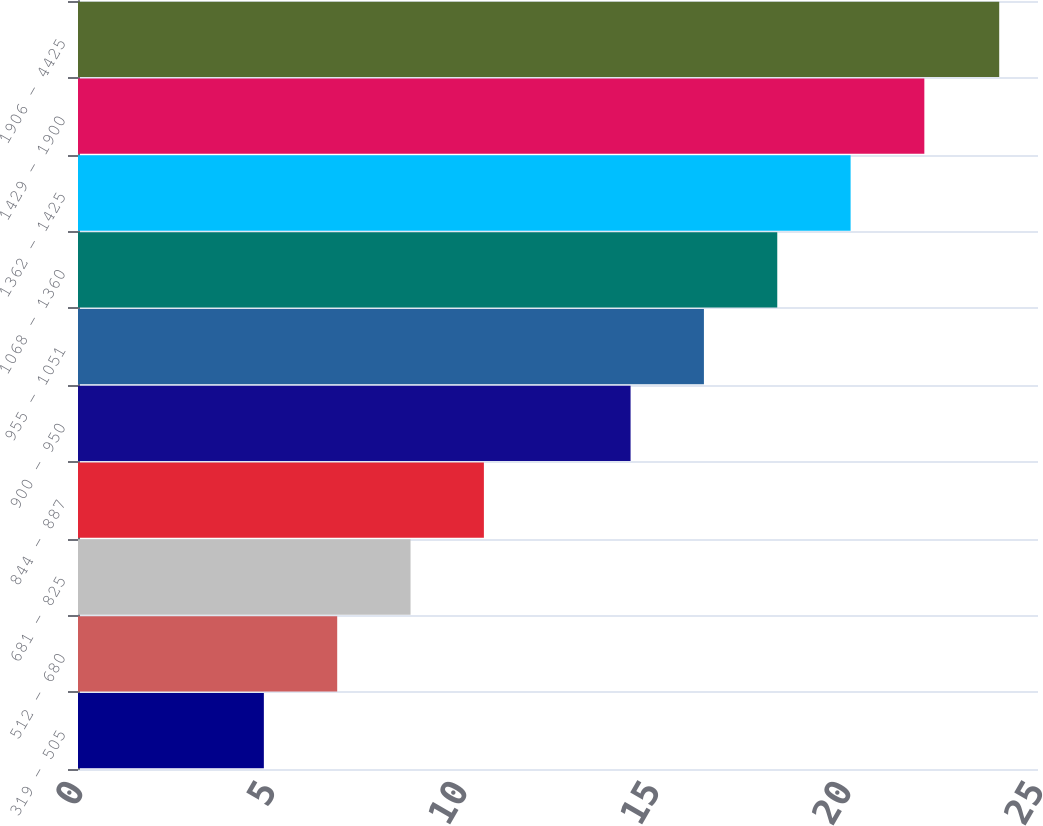Convert chart. <chart><loc_0><loc_0><loc_500><loc_500><bar_chart><fcel>319 - 505<fcel>512 - 680<fcel>681 - 825<fcel>844 - 887<fcel>900 - 950<fcel>955 - 1051<fcel>1068 - 1360<fcel>1362 - 1425<fcel>1429 - 1900<fcel>1906 - 4425<nl><fcel>4.84<fcel>6.75<fcel>8.66<fcel>10.57<fcel>14.39<fcel>16.3<fcel>18.21<fcel>20.12<fcel>22.04<fcel>23.99<nl></chart> 